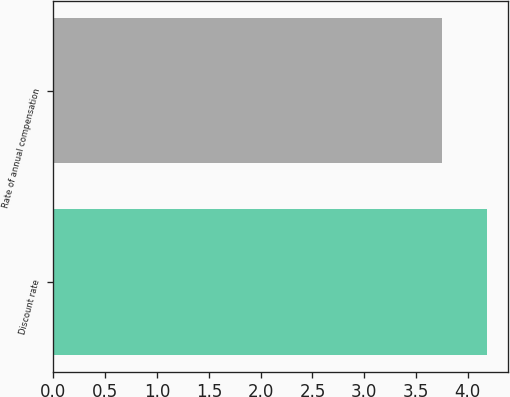<chart> <loc_0><loc_0><loc_500><loc_500><bar_chart><fcel>Discount rate<fcel>Rate of annual compensation<nl><fcel>4.18<fcel>3.75<nl></chart> 